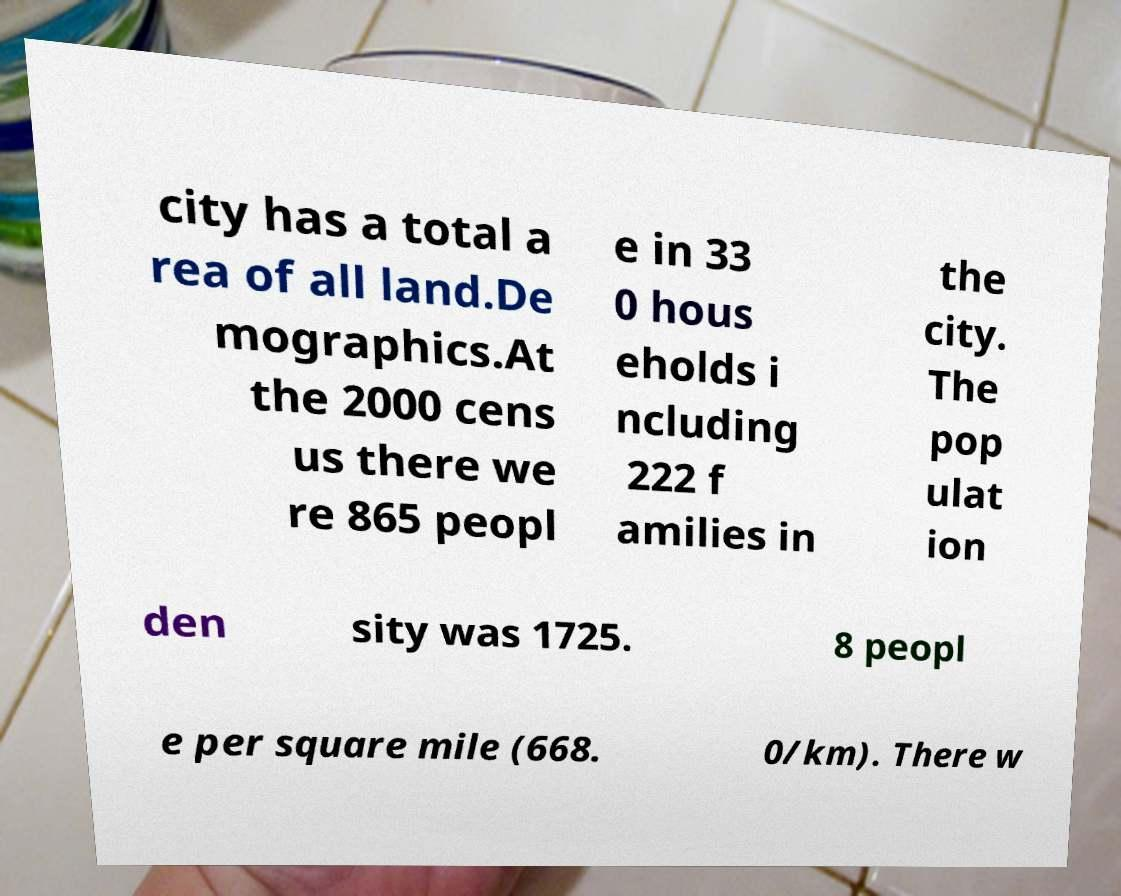Please identify and transcribe the text found in this image. city has a total a rea of all land.De mographics.At the 2000 cens us there we re 865 peopl e in 33 0 hous eholds i ncluding 222 f amilies in the city. The pop ulat ion den sity was 1725. 8 peopl e per square mile (668. 0/km). There w 